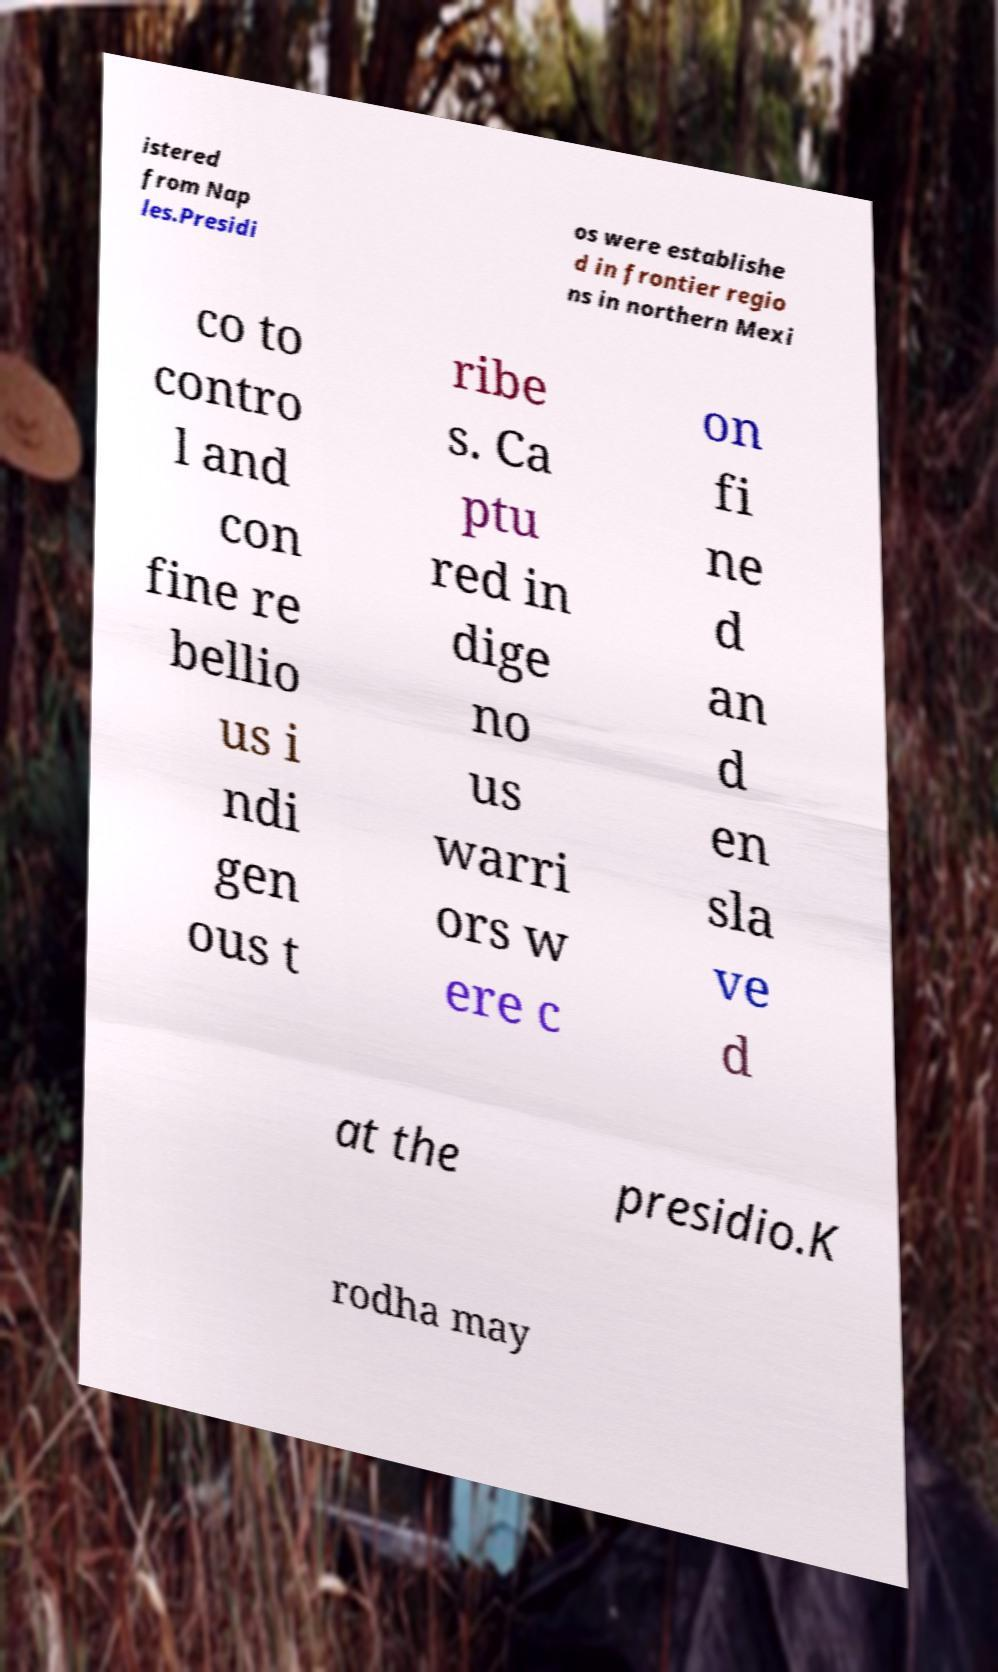Can you read and provide the text displayed in the image?This photo seems to have some interesting text. Can you extract and type it out for me? istered from Nap les.Presidi os were establishe d in frontier regio ns in northern Mexi co to contro l and con fine re bellio us i ndi gen ous t ribe s. Ca ptu red in dige no us warri ors w ere c on fi ne d an d en sla ve d at the presidio.K rodha may 